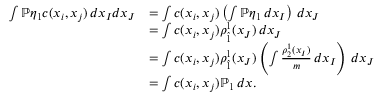Convert formula to latex. <formula><loc_0><loc_0><loc_500><loc_500>\begin{array} { r l } { \int \mathbb { P } \eta _ { 1 } c ( x _ { i } , x _ { j } ) \, d x _ { I } d x _ { J } } & { = \int c ( x _ { i } , x _ { j } ) \left ( \int \mathbb { P } \eta _ { 1 } \, d x _ { I } \right ) \, d x _ { J } } \\ & { = \int c ( x _ { i } , x _ { j } ) \rho _ { \hat { 1 } } ^ { 1 } ( x _ { J } ) \, d x _ { J } } \\ & { = \int c ( x _ { i } , x _ { j } ) \rho _ { \hat { 1 } } ^ { 1 } ( x _ { J } ) \left ( \int \frac { \rho _ { 2 } ^ { 1 } ( x _ { I } ) } m \, d x _ { I } \right ) \, d x _ { J } } \\ & { = \int c ( x _ { i } , x _ { j } ) \mathbb { P } _ { 1 } \, d x . } \end{array}</formula> 